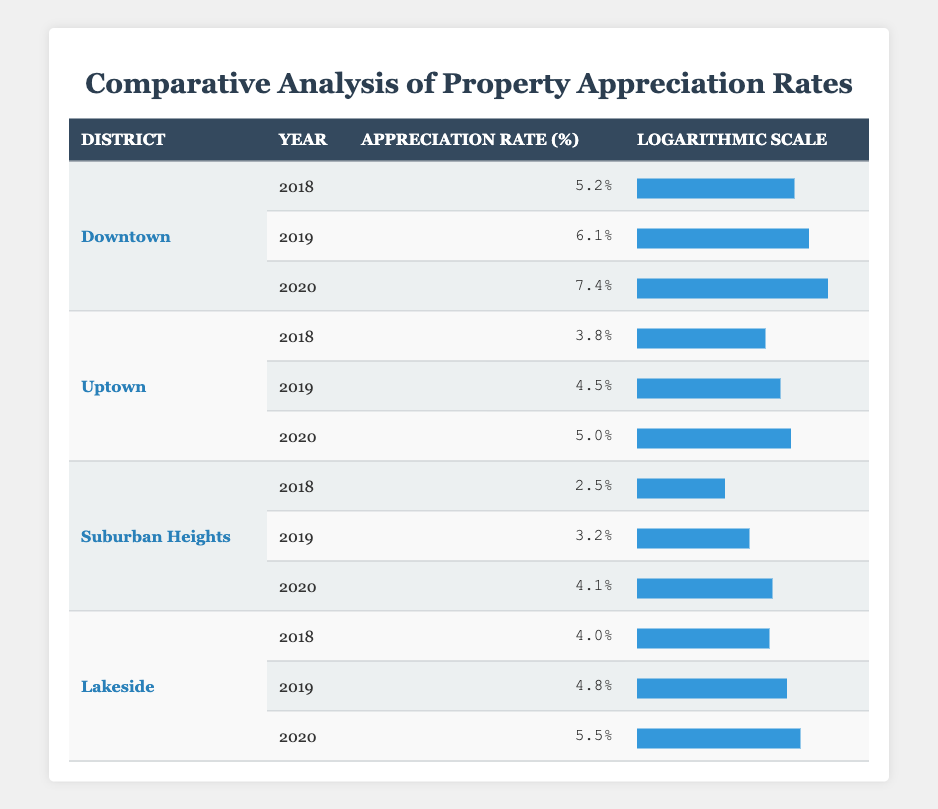What is the highest property appreciation rate recorded in the Downtown district? By looking at the table, we can see the appreciation rates for Downtown across three years: 5.2% in 2018, 6.1% in 2019, and 7.4% in 2020. The highest among these values is 7.4%.
Answer: 7.4% Which district had the lowest property appreciation rate in 2018? In 2018, the table shows the following rates: Downtown (5.2%), Uptown (3.8%), Suburban Heights (2.5%), and Lakeside (4.0%). The lowest rate is 2.5% in Suburban Heights.
Answer: Suburban Heights What was the average appreciation rate for Uptown over the years recorded? The appreciation rates for Uptown are: 3.8% (2018), 4.5% (2019), and 5.0% (2020). Adding these values gives 3.8 + 4.5 + 5.0 = 13.3%. Dividing the sum by 3 (the number of years) results in an average of 13.3% / 3 = 4.4333%, approximately 4.43%.
Answer: 4.43% Did Lakeside's appreciation rate ever exceed 5%? From the table, Lakeside's rates are: 4.0% (2018), 4.8% (2019), and 5.5% (2020). The rate of 5.5% in 2020 indicates that Lakeside did indeed exceed 5%.
Answer: Yes What is the difference between the highest and lowest appreciation rates in Suburban Heights? The rates for Suburban Heights over the years are: 2.5% (2018), 3.2% (2019), and 4.1% (2020). The highest rate is 4.1% and the lowest is 2.5%. The difference is calculated as 4.1% - 2.5% = 1.6%.
Answer: 1.6% What was the appreciation rate for Lakeside in 2019? Referring to the table, we see that Lakeside's appreciation rate for 2019 is listed as 4.8%.
Answer: 4.8% Which district showed the most consistent growth in appreciation rates from 2018 to 2020? Inspecting the rates, Downtown grows from 5.2% to 7.4%, Uptown from 3.8% to 5.0%, Suburban Heights from 2.5% to 4.1%, and Lakeside from 4.0% to 5.5%. Consistency can be gauged by the rate of increase. Downtown has a steady increase, but Lakeside's growth is also significant. Considering overall growth rate, Downtown has the highest increase (2.2% from 2018 to 2020). Thus, Downtown demonstrates the most consistent growth.
Answer: Downtown 